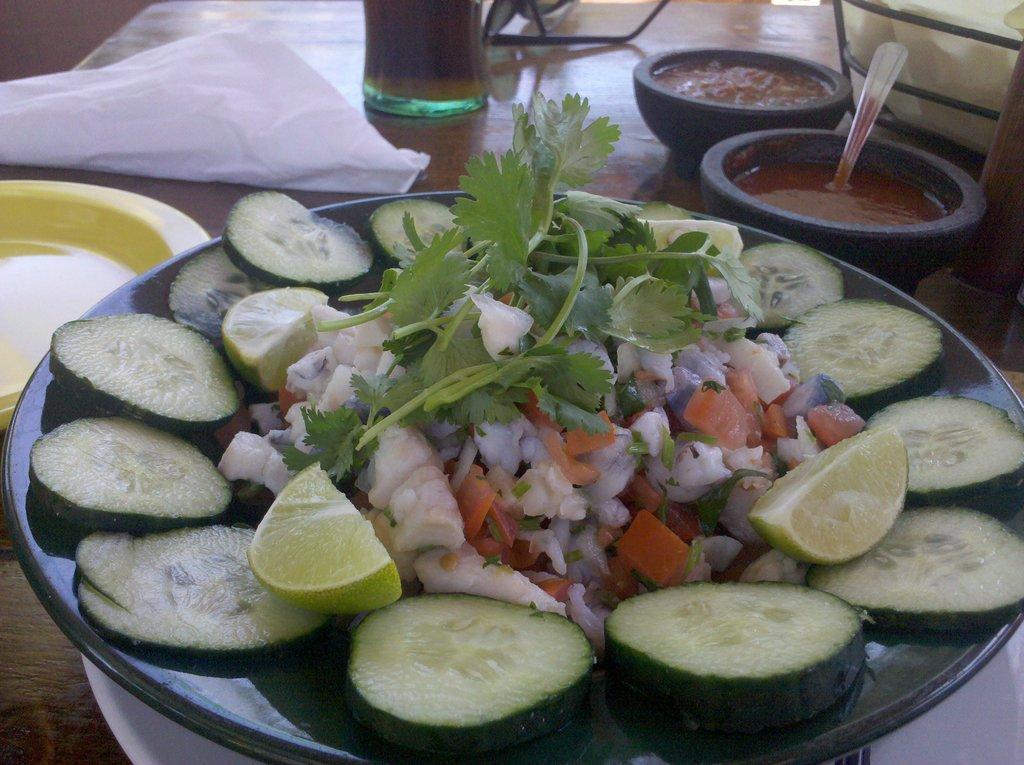Can you describe this image briefly? In this image on a dining table there are plates, bowls, glass, tissue and few other things. On the plate there is salad. In the bowl there is food is there. The glass is filled with drink. 